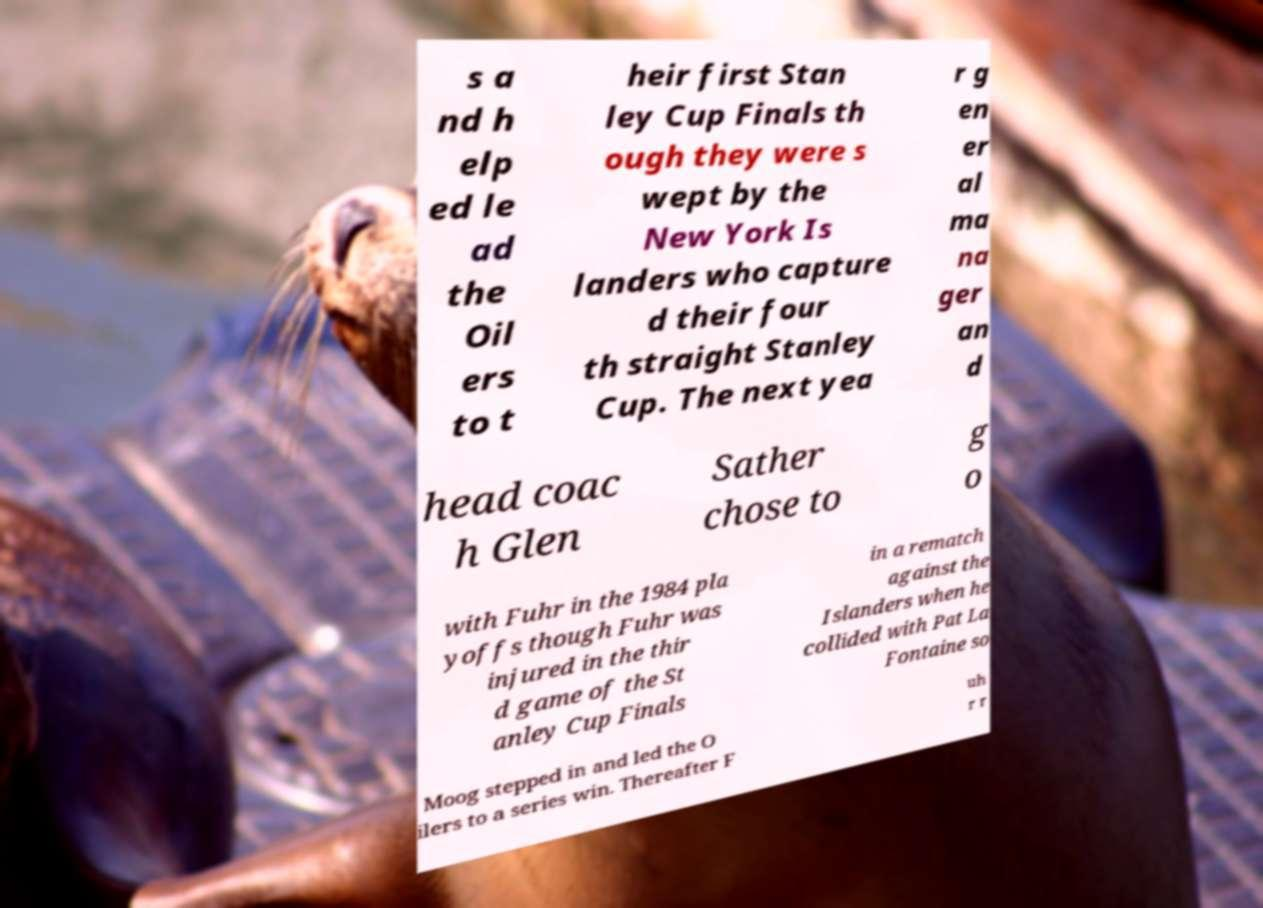Could you extract and type out the text from this image? s a nd h elp ed le ad the Oil ers to t heir first Stan ley Cup Finals th ough they were s wept by the New York Is landers who capture d their four th straight Stanley Cup. The next yea r g en er al ma na ger an d head coac h Glen Sather chose to g o with Fuhr in the 1984 pla yoffs though Fuhr was injured in the thir d game of the St anley Cup Finals in a rematch against the Islanders when he collided with Pat La Fontaine so Moog stepped in and led the O ilers to a series win. Thereafter F uh r r 